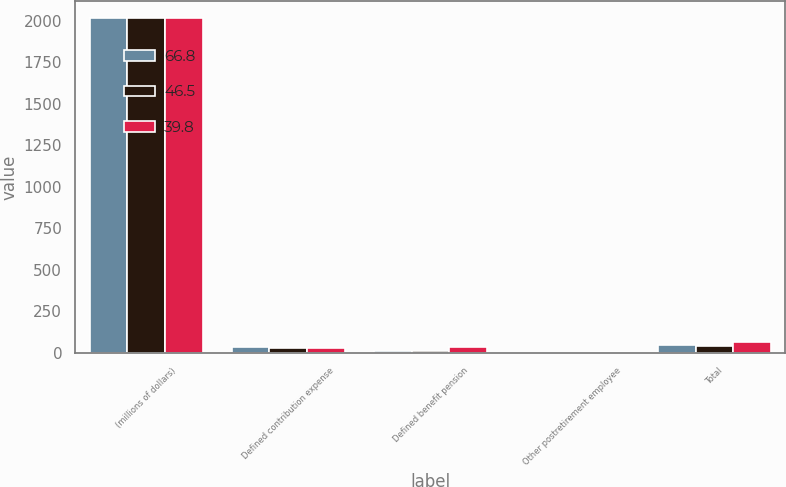Convert chart to OTSL. <chart><loc_0><loc_0><loc_500><loc_500><stacked_bar_chart><ecel><fcel>(millions of dollars)<fcel>Defined contribution expense<fcel>Defined benefit pension<fcel>Other postretirement employee<fcel>Total<nl><fcel>66.8<fcel>2017<fcel>33.5<fcel>12.5<fcel>0.5<fcel>46.5<nl><fcel>46.5<fcel>2016<fcel>28.3<fcel>10.1<fcel>1.4<fcel>39.8<nl><fcel>39.8<fcel>2015<fcel>28<fcel>35.5<fcel>3.3<fcel>66.8<nl></chart> 